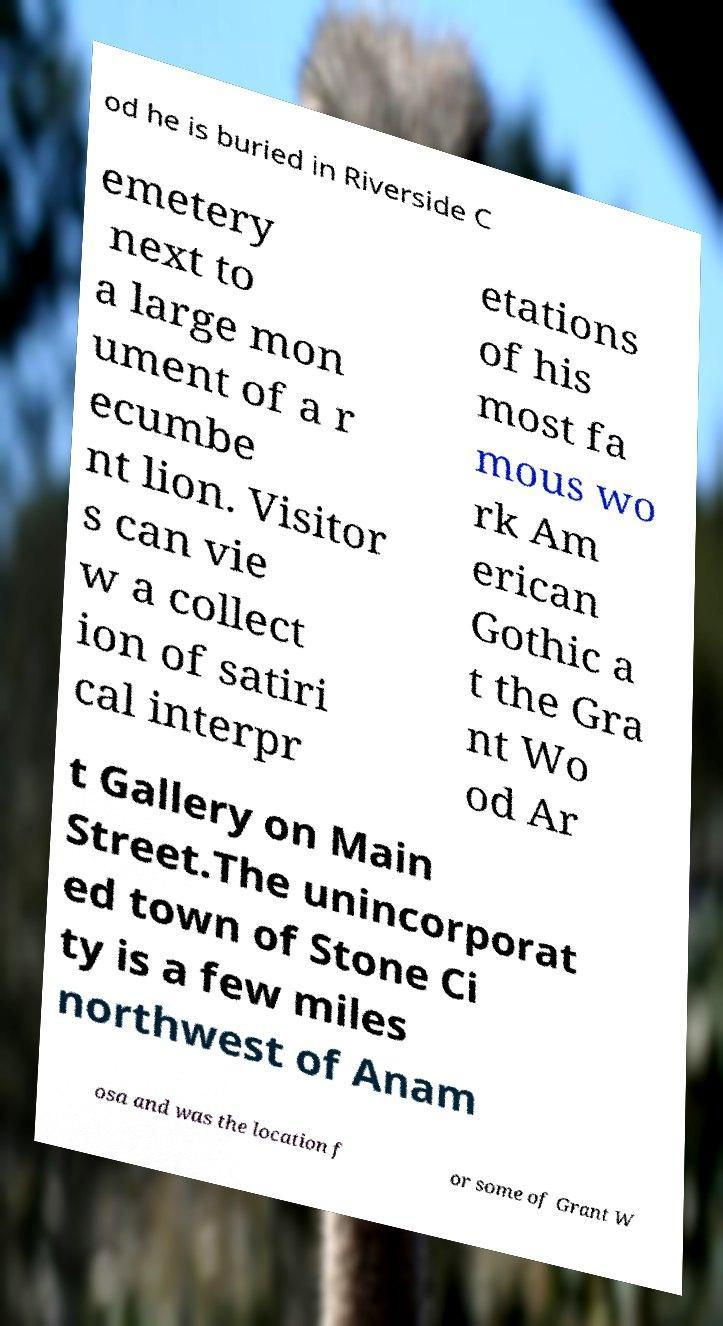There's text embedded in this image that I need extracted. Can you transcribe it verbatim? od he is buried in Riverside C emetery next to a large mon ument of a r ecumbe nt lion. Visitor s can vie w a collect ion of satiri cal interpr etations of his most fa mous wo rk Am erican Gothic a t the Gra nt Wo od Ar t Gallery on Main Street.The unincorporat ed town of Stone Ci ty is a few miles northwest of Anam osa and was the location f or some of Grant W 